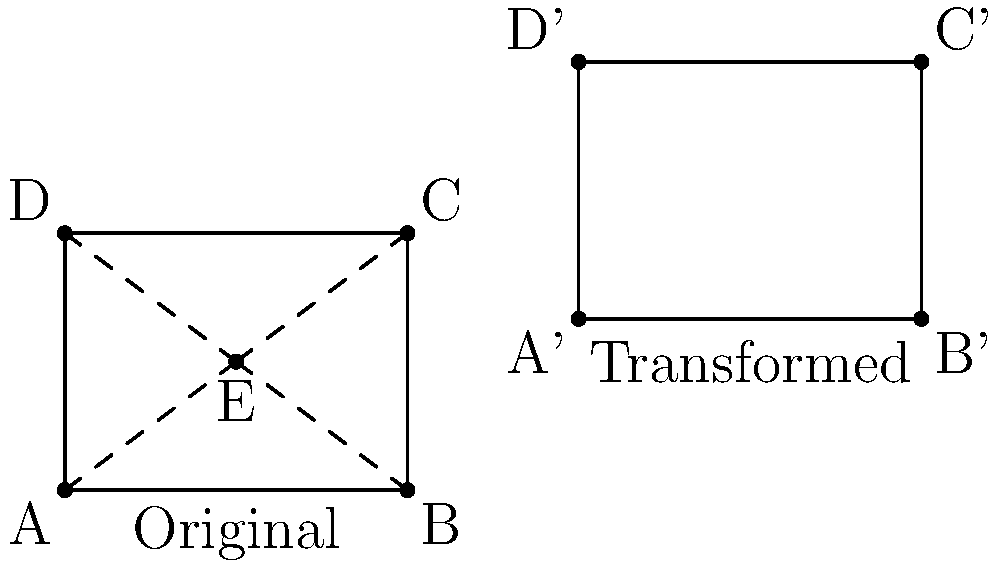In the context of perspective drawing, consider the transformation of a square ABCD with a central vanishing point E to a new position A'B'C'D'. If this transformation involves a translation of 6 units to the right and 2 units up, followed by a dilation with scale factor 1.5 from the point (0,0), what is the area of the transformed square A'B'C'D' in terms of the area of the original square ABCD? Let's approach this step-by-step:

1) First, let's consider the translation:
   - The square is moved 6 units right and 2 units up.
   - This doesn't change the size of the square, only its position.

2) Next, we apply the dilation:
   - The dilation has a scale factor of 1.5 from the point (0,0).
   - In a dilation, all linear dimensions are multiplied by the scale factor.

3) Effect on area:
   - Area is a two-dimensional measure.
   - When linear dimensions are multiplied by a factor k, the area is multiplied by $k^2$.

4) Calculating the area change:
   - The scale factor for linear dimensions is 1.5.
   - For area, we square this: $1.5^2 = 2.25$

5) Final result:
   - The area of A'B'C'D' is 2.25 times the area of ABCD.

Therefore, if we denote the area of ABCD as A, the area of A'B'C'D' is $2.25A$.
Answer: $2.25A$ 